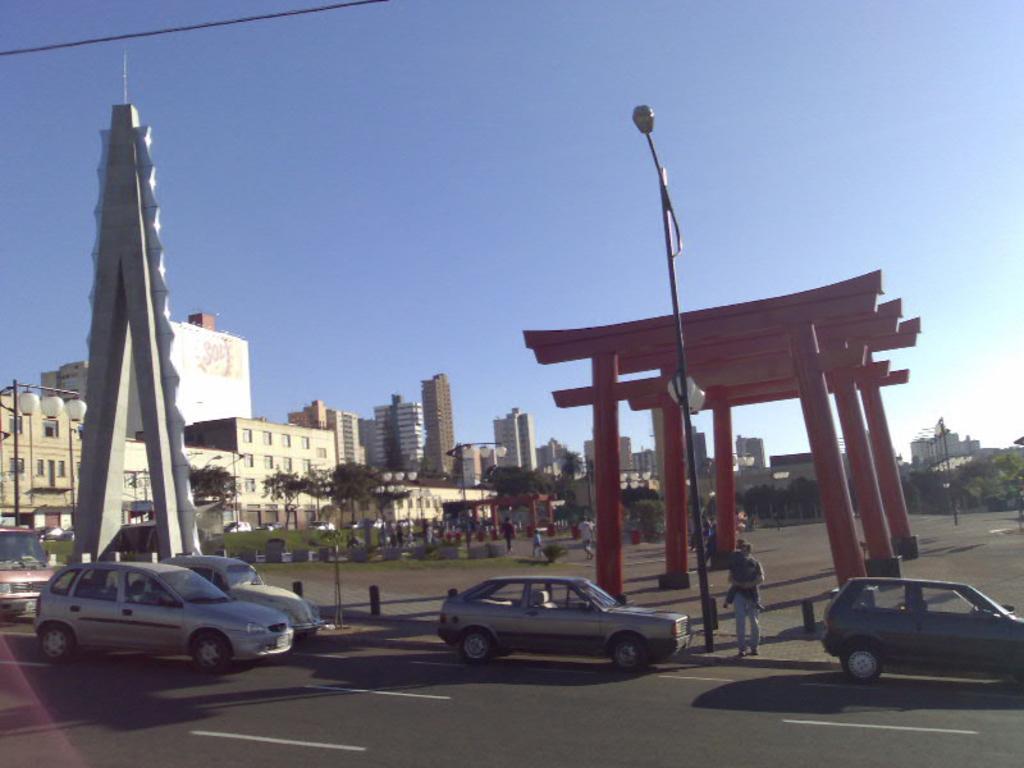Describe this image in one or two sentences. Here few vehicles are moving on the road, in the left side there are buildings. At the top it is a sky. 